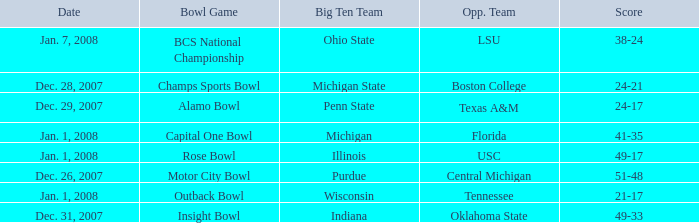What bowl game was played on Dec. 26, 2007? Motor City Bowl. 